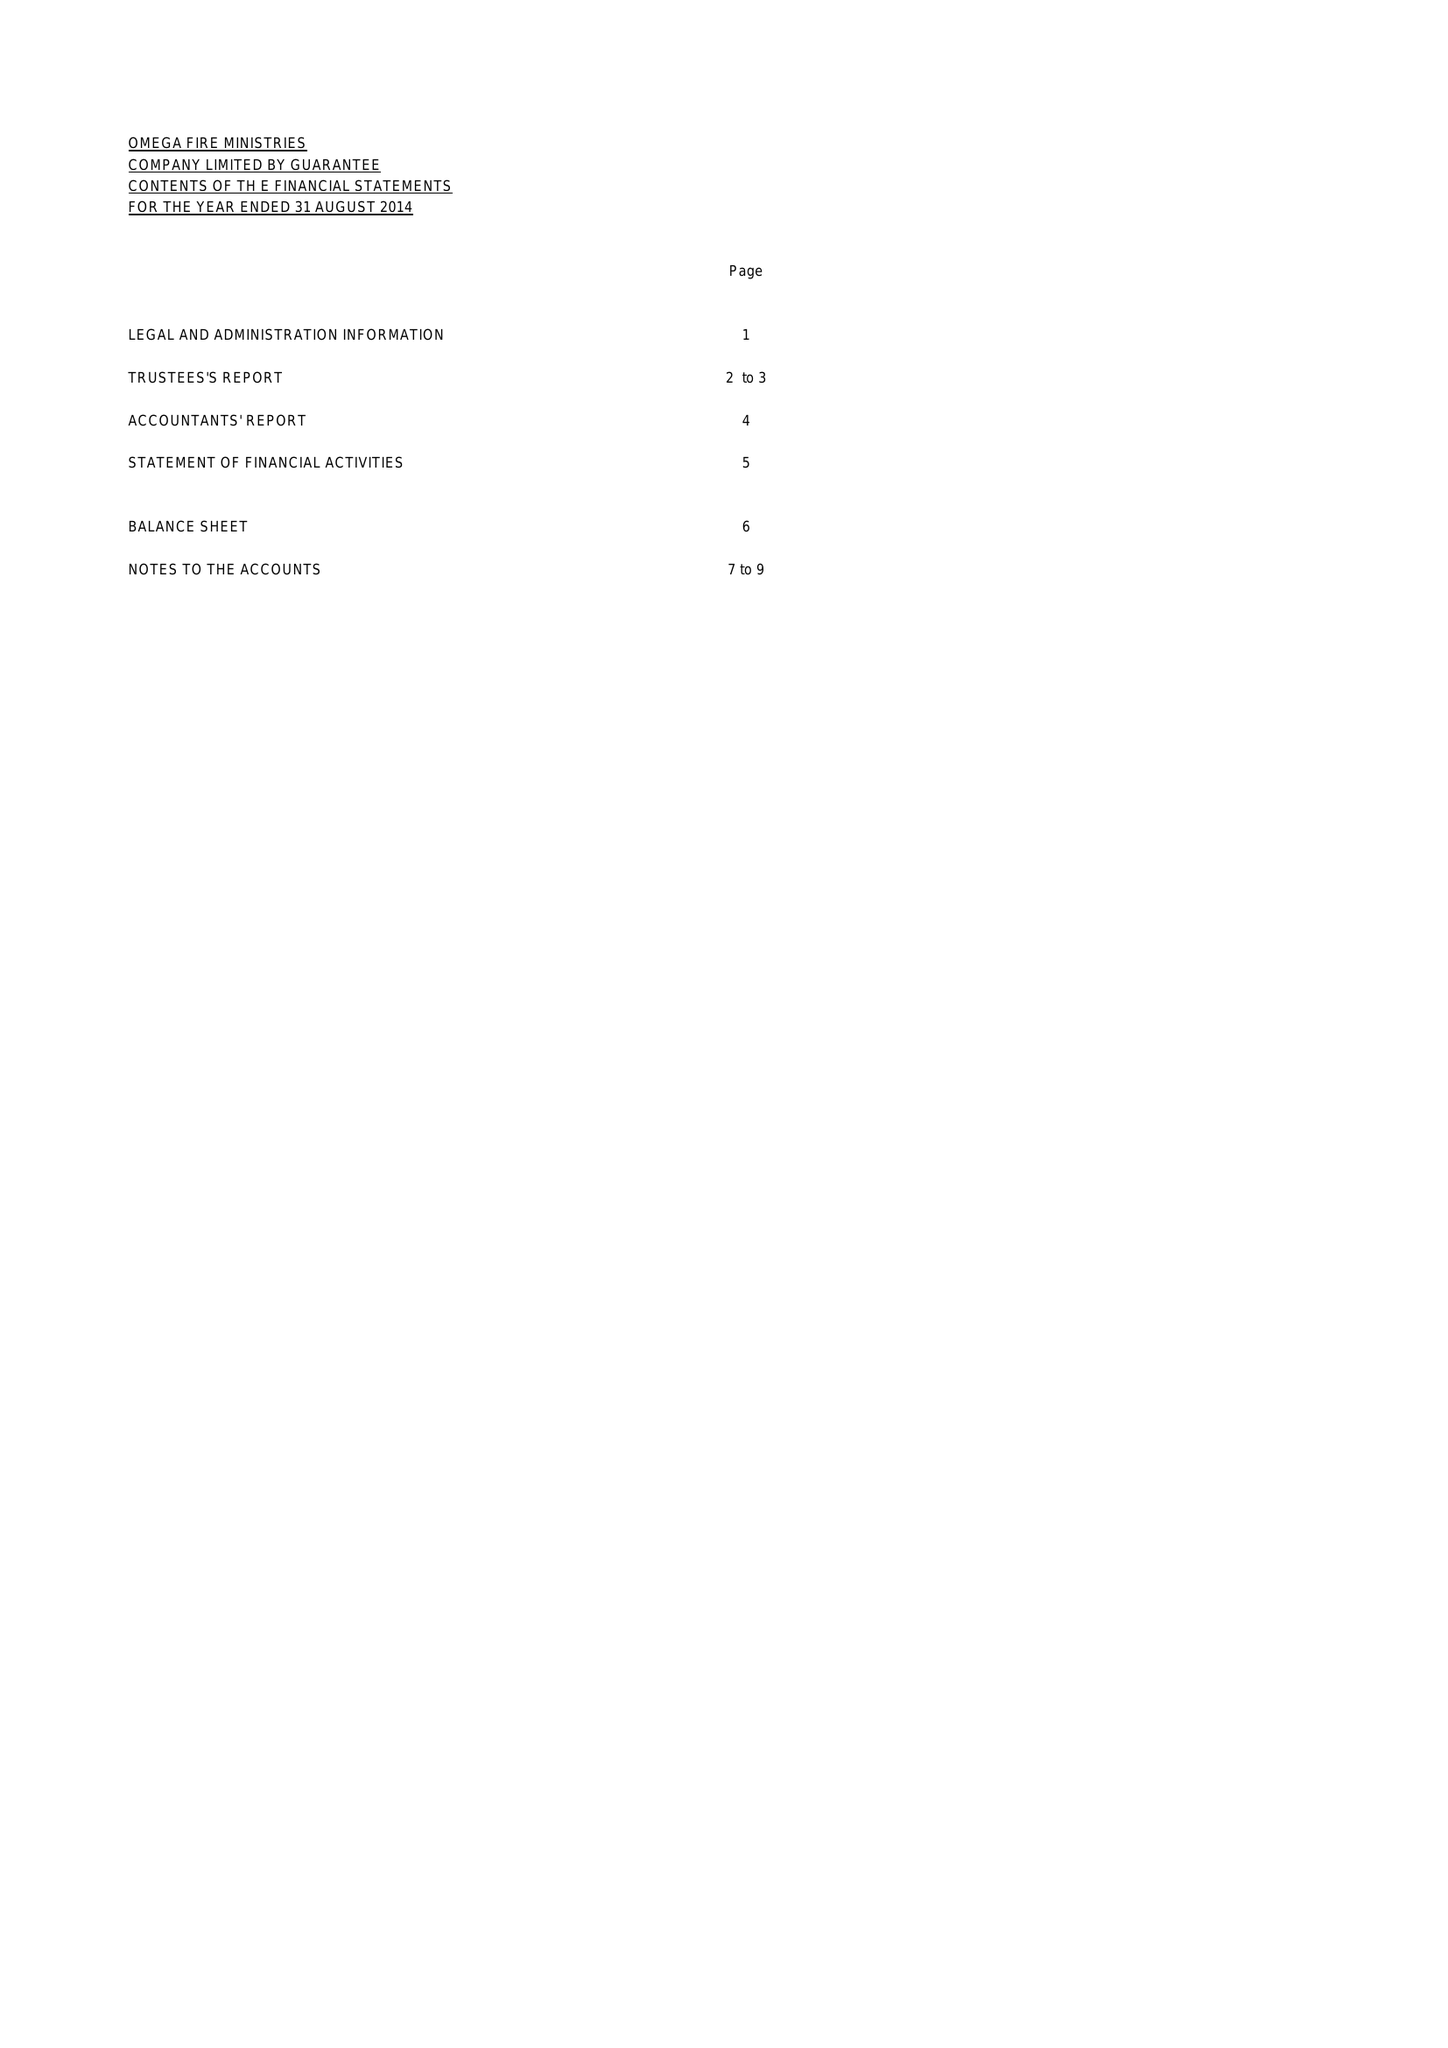What is the value for the income_annually_in_british_pounds?
Answer the question using a single word or phrase. 27944.00 